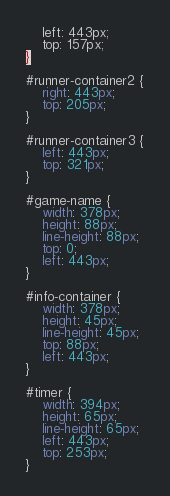Convert code to text. <code><loc_0><loc_0><loc_500><loc_500><_CSS_>	left: 443px;
	top: 157px;
}

#runner-container2 {
	right: 443px;
	top: 205px;
}

#runner-container3 {
	left: 443px;
	top: 321px;
}

#game-name {
	width: 378px;
	height: 88px;
	line-height: 88px;
	top: 0;
	left: 443px;
}

#info-container {
	width: 378px;
	height: 45px;
	line-height: 45px;
	top: 88px;
	left: 443px;
}

#timer {
	width: 394px;
	height: 65px;
	line-height: 65px;
	left: 443px;
	top: 253px;
}</code> 